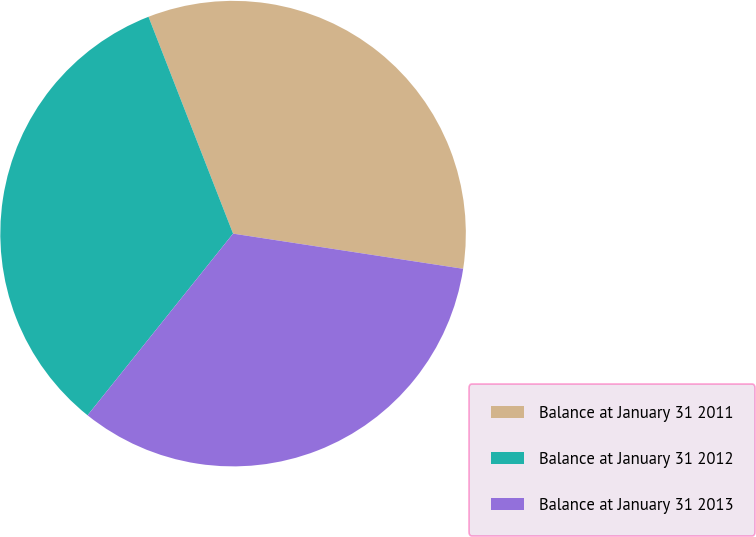<chart> <loc_0><loc_0><loc_500><loc_500><pie_chart><fcel>Balance at January 31 2011<fcel>Balance at January 31 2012<fcel>Balance at January 31 2013<nl><fcel>33.33%<fcel>33.33%<fcel>33.33%<nl></chart> 